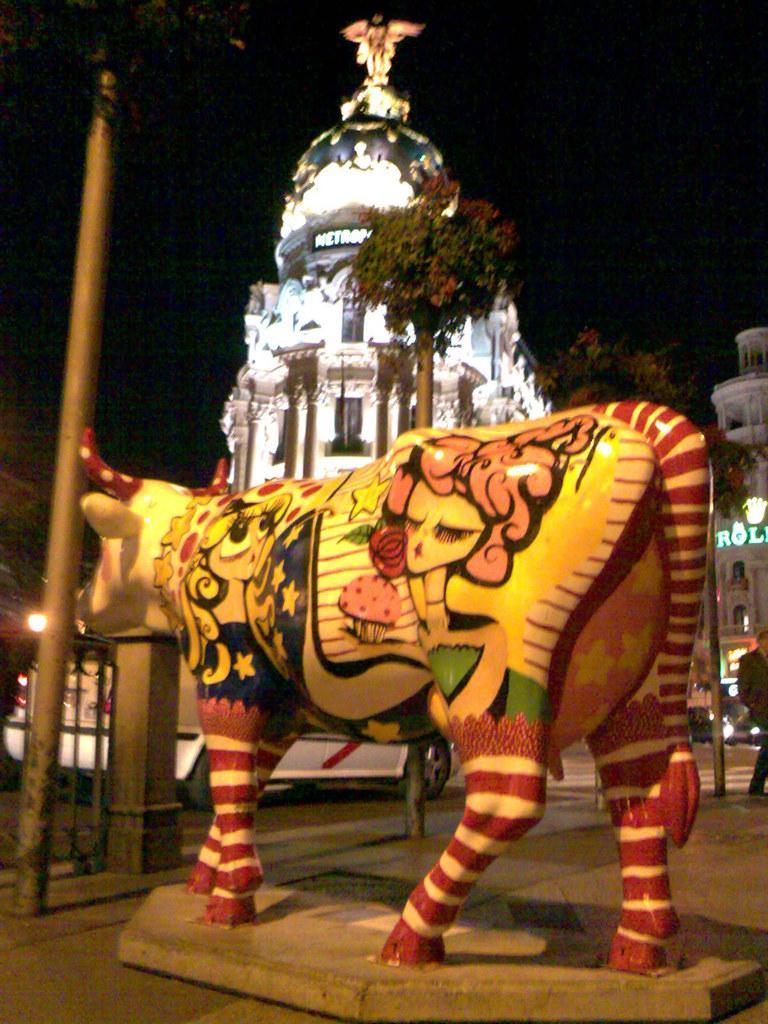Can you describe this image briefly? Here we can see a colorful animal statue. This is a pole. In the background we can see trees and buildings. We can see a person at the left side of the picture. 